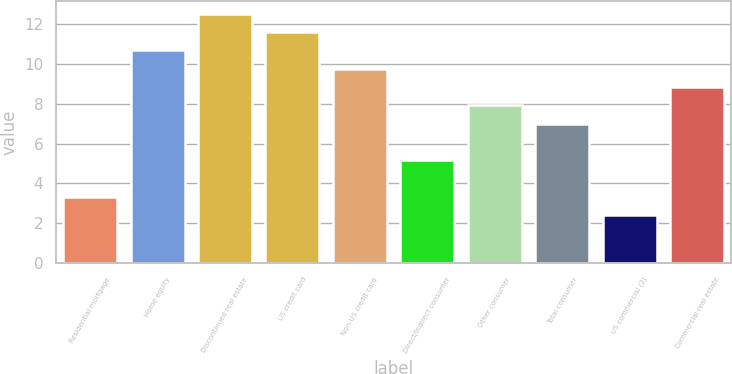Convert chart to OTSL. <chart><loc_0><loc_0><loc_500><loc_500><bar_chart><fcel>Residential mortgage<fcel>Home equity<fcel>Discontinued real estate<fcel>US credit card<fcel>Non-US credit card<fcel>Direct/Indirect consumer<fcel>Other consumer<fcel>Total consumer<fcel>US commercial (2)<fcel>Commercial real estate<nl><fcel>3.33<fcel>10.69<fcel>12.53<fcel>11.61<fcel>9.77<fcel>5.17<fcel>7.93<fcel>7.01<fcel>2.41<fcel>8.85<nl></chart> 